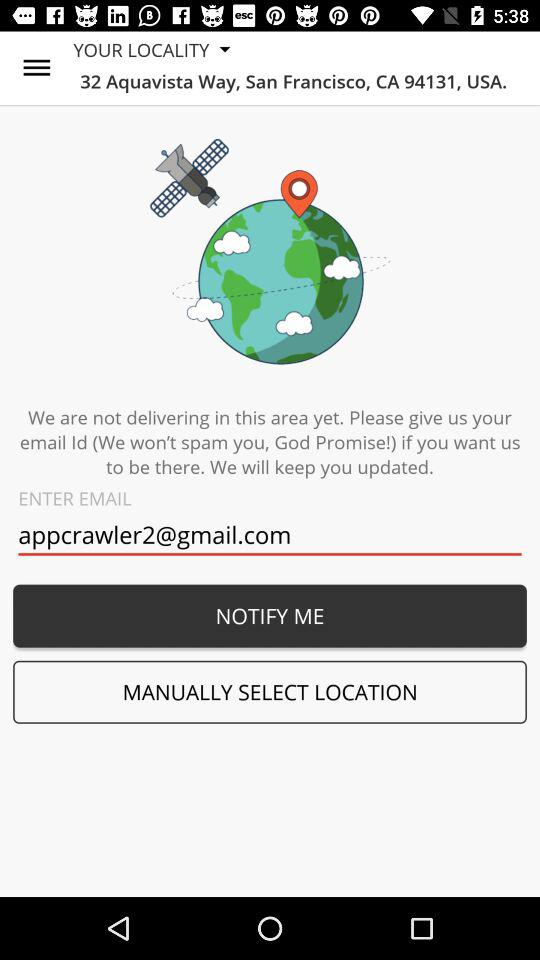What is the given email address? The given email address is appcrawler2@gmail.com. 